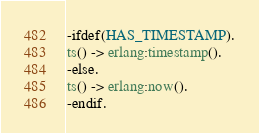Convert code to text. <code><loc_0><loc_0><loc_500><loc_500><_Erlang_>-ifdef(HAS_TIMESTAMP).
ts() -> erlang:timestamp().
-else.
ts() -> erlang:now().
-endif.
</code> 